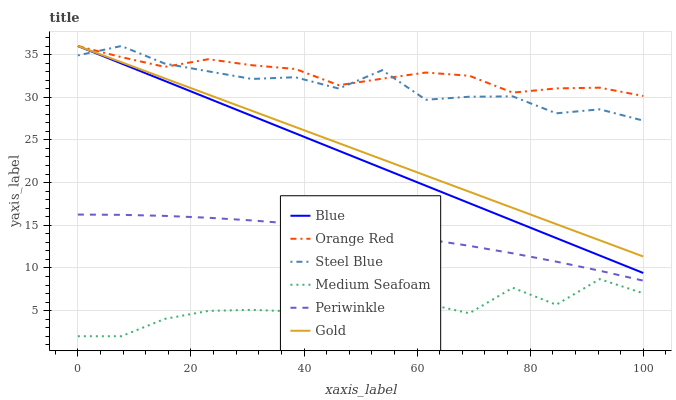Does Medium Seafoam have the minimum area under the curve?
Answer yes or no. Yes. Does Orange Red have the maximum area under the curve?
Answer yes or no. Yes. Does Gold have the minimum area under the curve?
Answer yes or no. No. Does Gold have the maximum area under the curve?
Answer yes or no. No. Is Gold the smoothest?
Answer yes or no. Yes. Is Medium Seafoam the roughest?
Answer yes or no. Yes. Is Steel Blue the smoothest?
Answer yes or no. No. Is Steel Blue the roughest?
Answer yes or no. No. Does Medium Seafoam have the lowest value?
Answer yes or no. Yes. Does Gold have the lowest value?
Answer yes or no. No. Does Orange Red have the highest value?
Answer yes or no. Yes. Does Periwinkle have the highest value?
Answer yes or no. No. Is Medium Seafoam less than Blue?
Answer yes or no. Yes. Is Orange Red greater than Periwinkle?
Answer yes or no. Yes. Does Orange Red intersect Gold?
Answer yes or no. Yes. Is Orange Red less than Gold?
Answer yes or no. No. Is Orange Red greater than Gold?
Answer yes or no. No. Does Medium Seafoam intersect Blue?
Answer yes or no. No. 